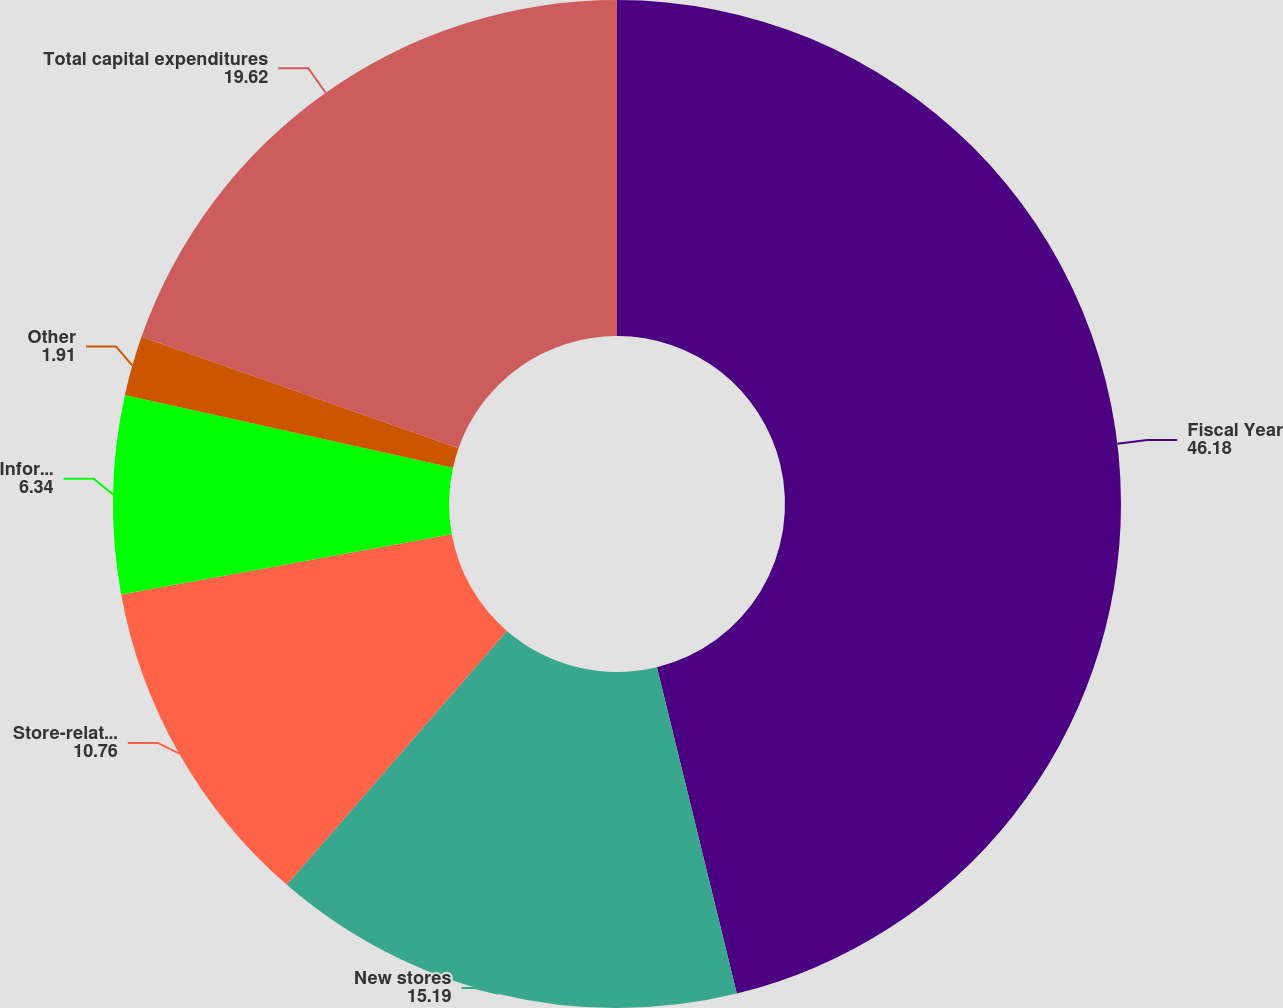Convert chart to OTSL. <chart><loc_0><loc_0><loc_500><loc_500><pie_chart><fcel>Fiscal Year<fcel>New stores<fcel>Store-related projects (1)<fcel>Information technology<fcel>Other<fcel>Total capital expenditures<nl><fcel>46.18%<fcel>15.19%<fcel>10.76%<fcel>6.34%<fcel>1.91%<fcel>19.62%<nl></chart> 